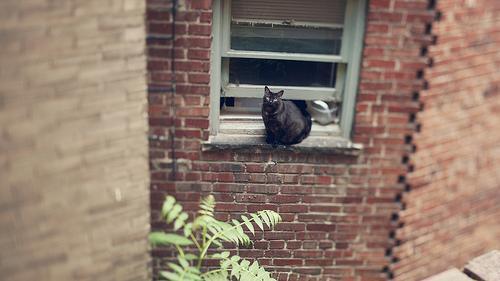How many trees are visible?
Give a very brief answer. 1. 